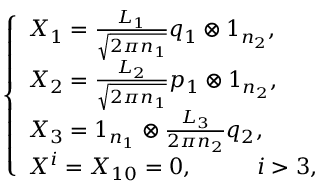Convert formula to latex. <formula><loc_0><loc_0><loc_500><loc_500>\left \{ \begin{array} { l l l } { { X _ { 1 } = \frac { L _ { 1 } } { \sqrt { 2 \pi n _ { 1 } } } q _ { 1 } \otimes 1 _ { n _ { 2 } } , } } \\ { { X _ { 2 } = \frac { L _ { 2 } } { \sqrt { 2 \pi n _ { 1 } } } p _ { 1 } \otimes 1 _ { n _ { 2 } } , } } \\ { { X _ { 3 } = 1 _ { n _ { 1 } } \otimes \frac { L _ { 3 } } { 2 \pi n _ { 2 } } q _ { 2 } , } } \\ { { X ^ { i } = X _ { 1 0 } = 0 , \, i > 3 , } } \end{array}</formula> 